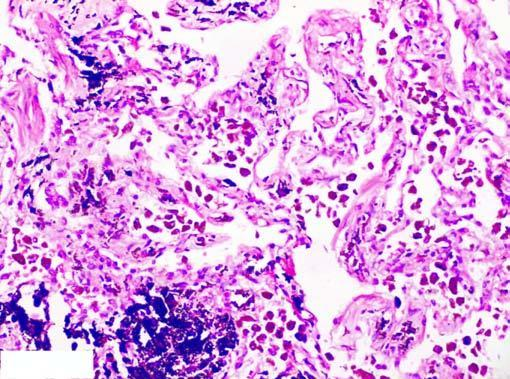what is there in the septal walls and around the bronchiole?
Answer the question using a single word or phrase. Presence of abundant coarse black carbon pigment bronchiole 